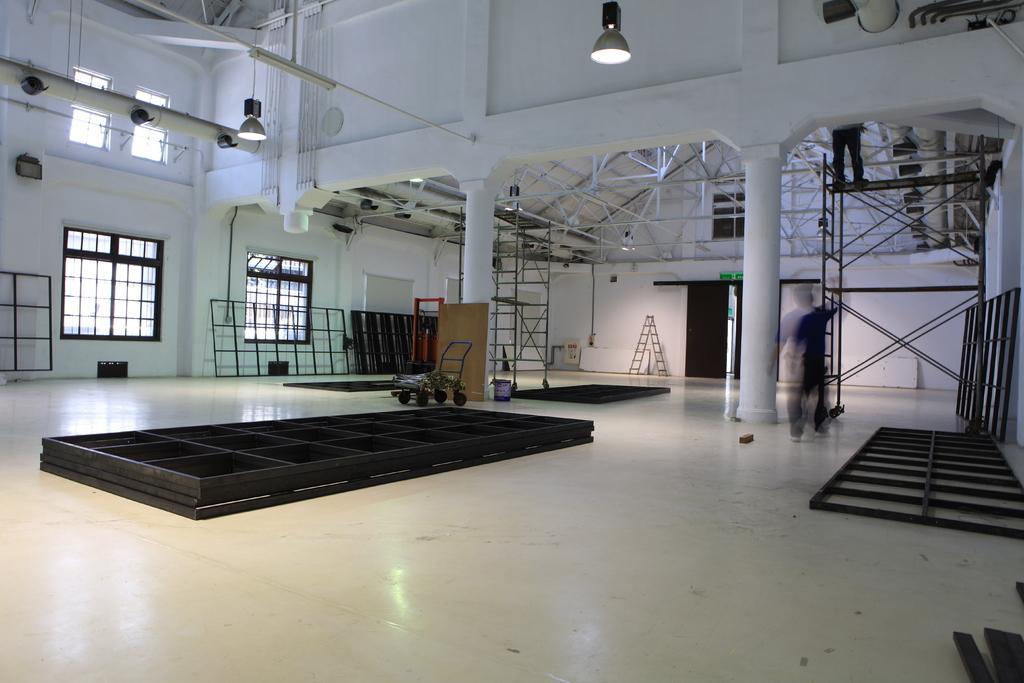In one or two sentences, can you explain what this image depicts? In the picture I can see few iron rods and there is a person standing and there is another person standing in front of him on a iron stand and there are few lights attached to the roof and there are few glass windows in the background. 